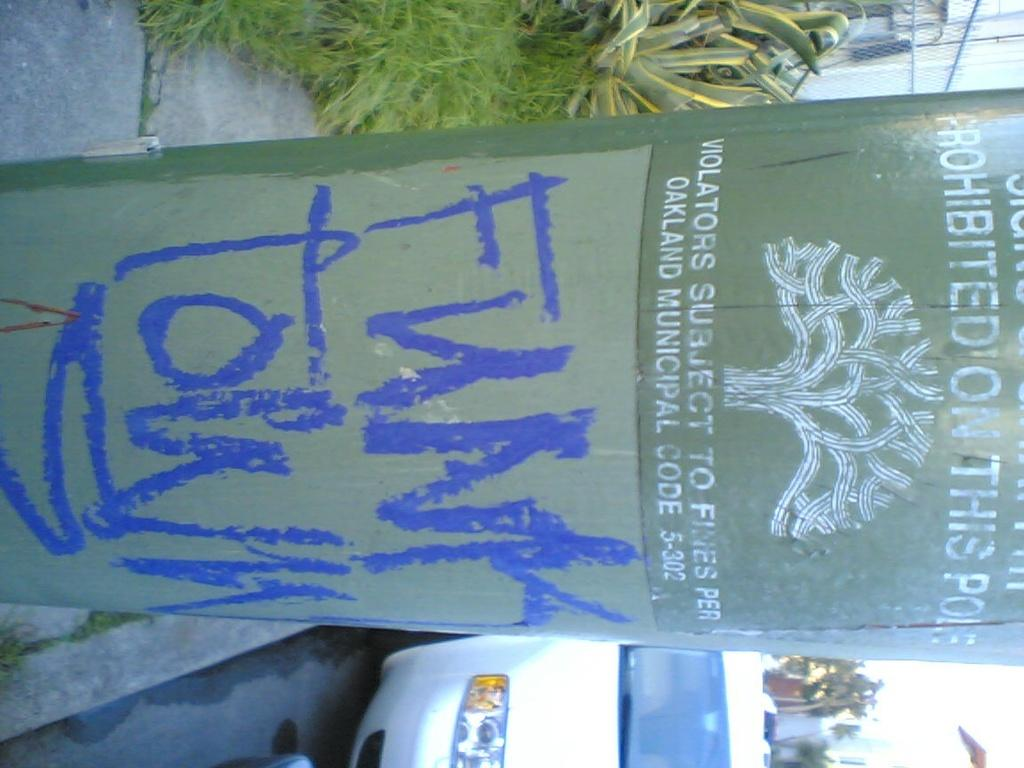What is the main object in the image? There is a pole in the image. What can be seen behind the pole? There are plants behind the pole. What else is visible in the image? There is a car on the right side of the image. What type of food is being prepared on the pole in the image? There is no food preparation or cooking activity taking place on the pole in the image. 